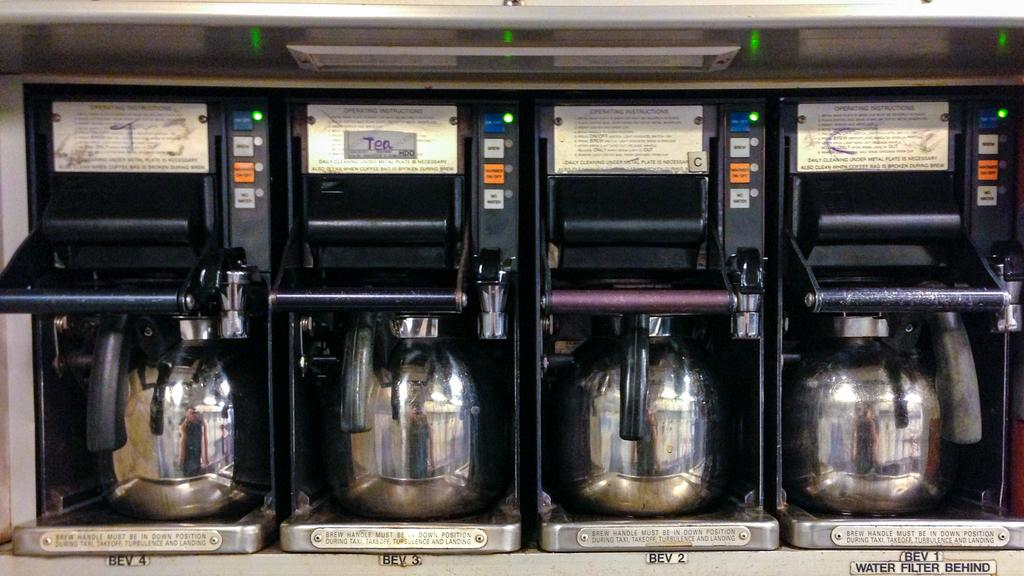Provide a one-sentence caption for the provided image. One of the options to drink is tea. 